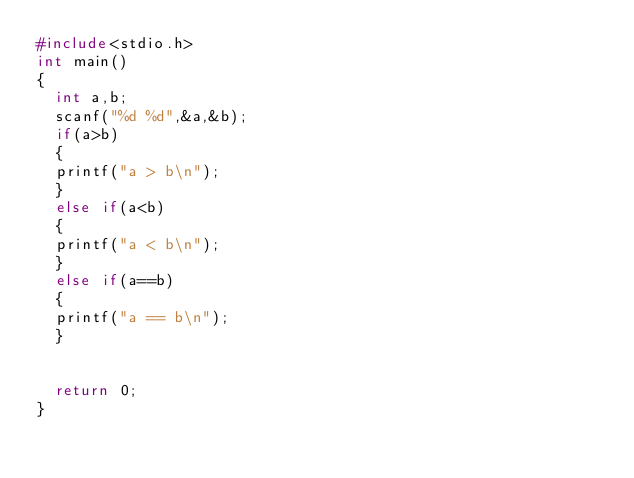Convert code to text. <code><loc_0><loc_0><loc_500><loc_500><_C++_>#include<stdio.h>
int main()
{
	int a,b;
	scanf("%d %d",&a,&b);
	if(a>b)
	{
	printf("a > b\n");
	}
	else if(a<b)
	{
	printf("a < b\n");
	}
	else if(a==b)
	{
	printf("a == b\n");
	}
	
	
	return 0;
}</code> 